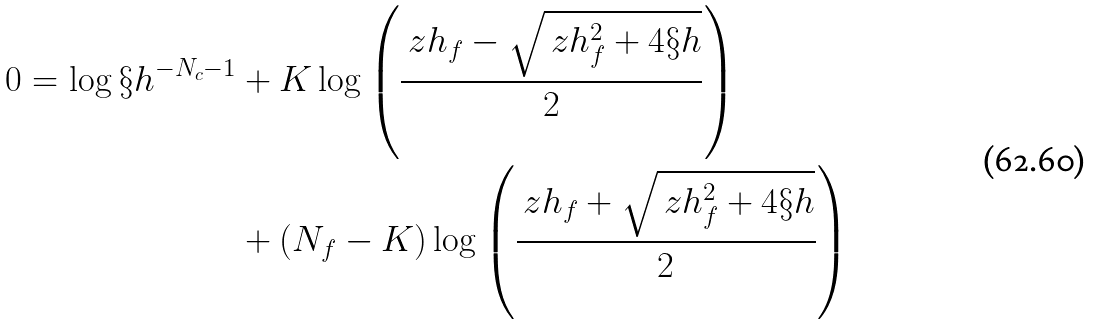<formula> <loc_0><loc_0><loc_500><loc_500>0 = \log \S h ^ { - N _ { c } - 1 } & + K \log \left ( \frac { \ z h _ { f } - \sqrt { \ z h _ { f } ^ { 2 } + 4 \S h } } { 2 } \right ) \\ & + \left ( N _ { f } - K \right ) \log \left ( \frac { \ z h _ { f } + \sqrt { \ z h _ { f } ^ { 2 } + 4 \S h } } { 2 } \right )</formula> 